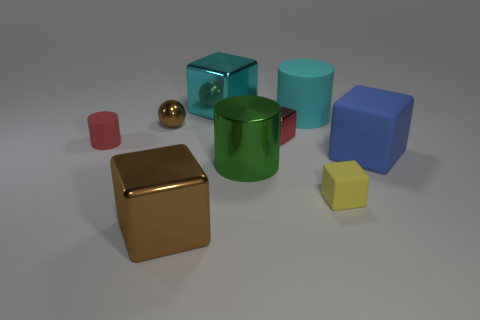Subtract all yellow blocks. How many blocks are left? 4 Subtract 1 blocks. How many blocks are left? 4 Add 1 big cyan blocks. How many objects exist? 10 Subtract all red blocks. How many blocks are left? 4 Subtract all blocks. How many objects are left? 4 Subtract all purple cylinders. Subtract all brown spheres. How many cylinders are left? 3 Subtract all big cyan cylinders. Subtract all small metal cubes. How many objects are left? 7 Add 4 blue things. How many blue things are left? 5 Add 5 big blue rubber cylinders. How many big blue rubber cylinders exist? 5 Subtract 0 green balls. How many objects are left? 9 